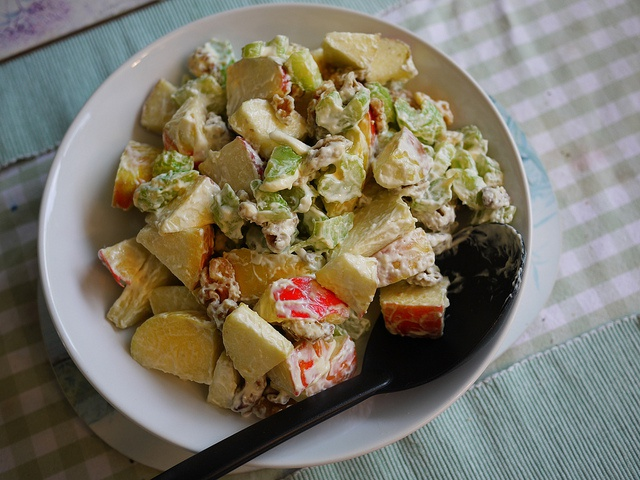Describe the objects in this image and their specific colors. I can see bowl in gray, darkgray, olive, black, and tan tones, spoon in gray and black tones, apple in gray, olive, and tan tones, apple in gray, olive, maroon, and tan tones, and apple in gray, tan, and olive tones in this image. 